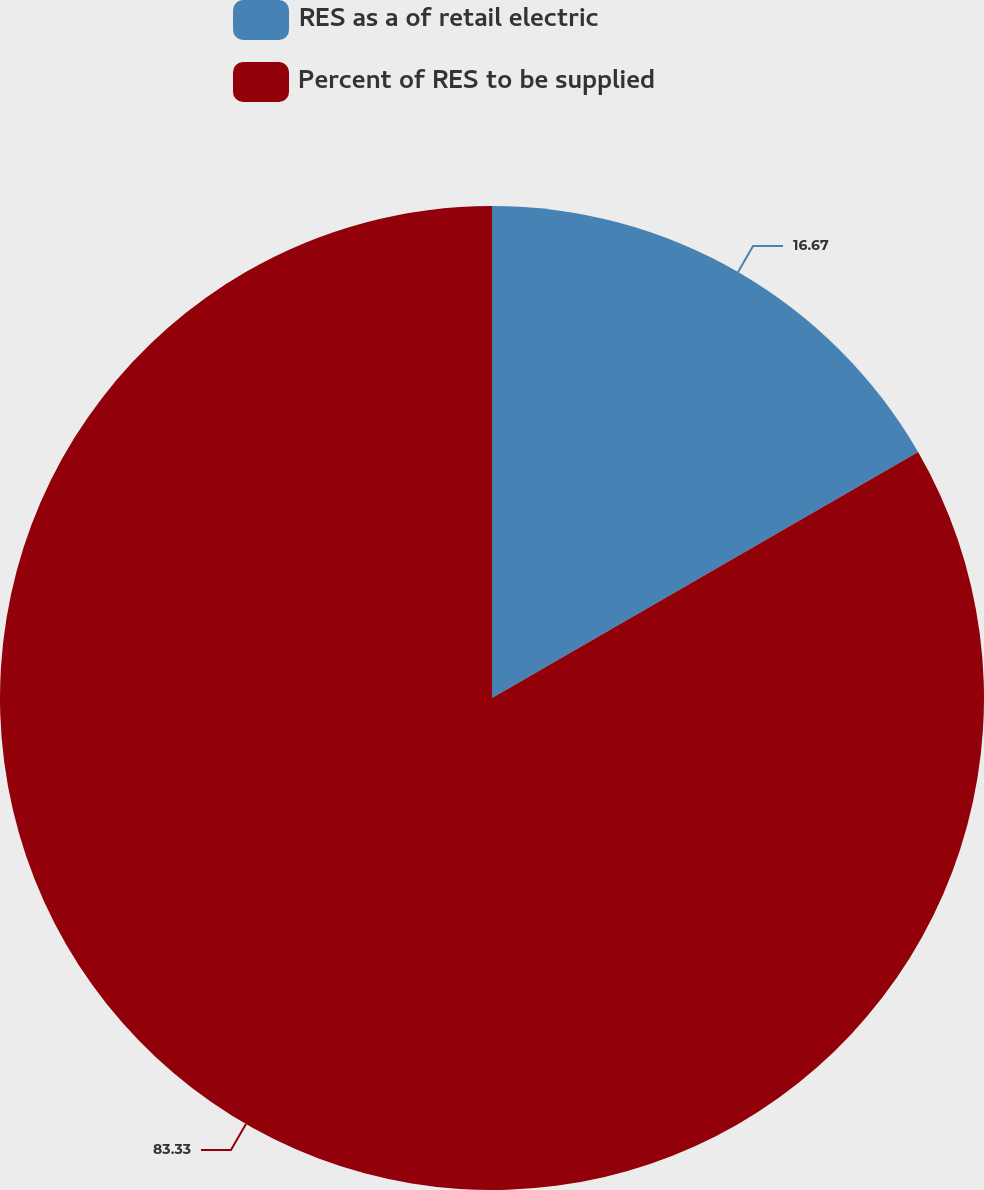Convert chart to OTSL. <chart><loc_0><loc_0><loc_500><loc_500><pie_chart><fcel>RES as a of retail electric<fcel>Percent of RES to be supplied<nl><fcel>16.67%<fcel>83.33%<nl></chart> 